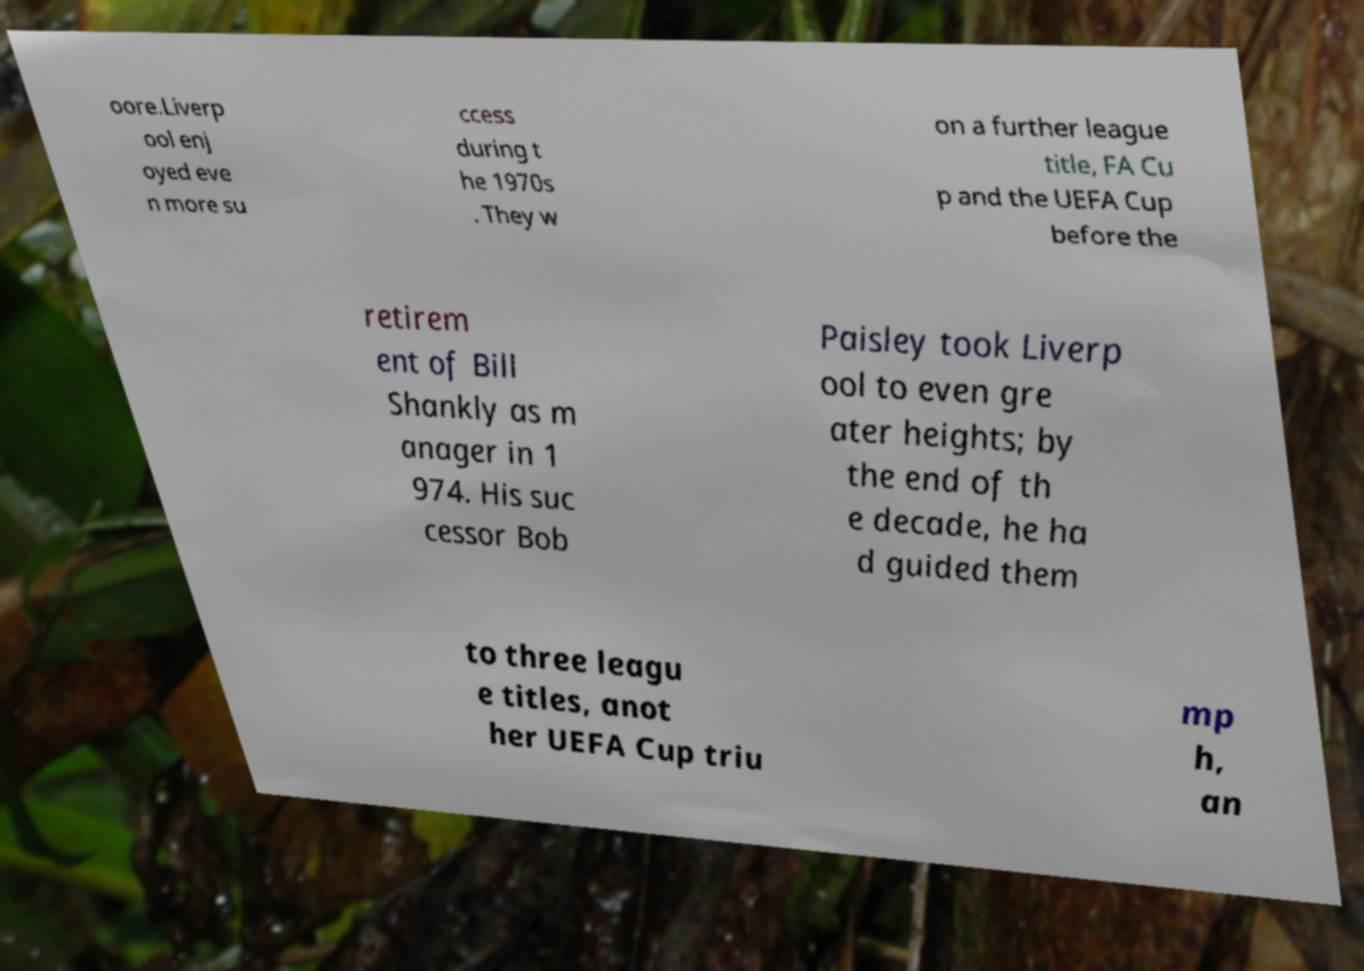Please read and relay the text visible in this image. What does it say? oore.Liverp ool enj oyed eve n more su ccess during t he 1970s . They w on a further league title, FA Cu p and the UEFA Cup before the retirem ent of Bill Shankly as m anager in 1 974. His suc cessor Bob Paisley took Liverp ool to even gre ater heights; by the end of th e decade, he ha d guided them to three leagu e titles, anot her UEFA Cup triu mp h, an 